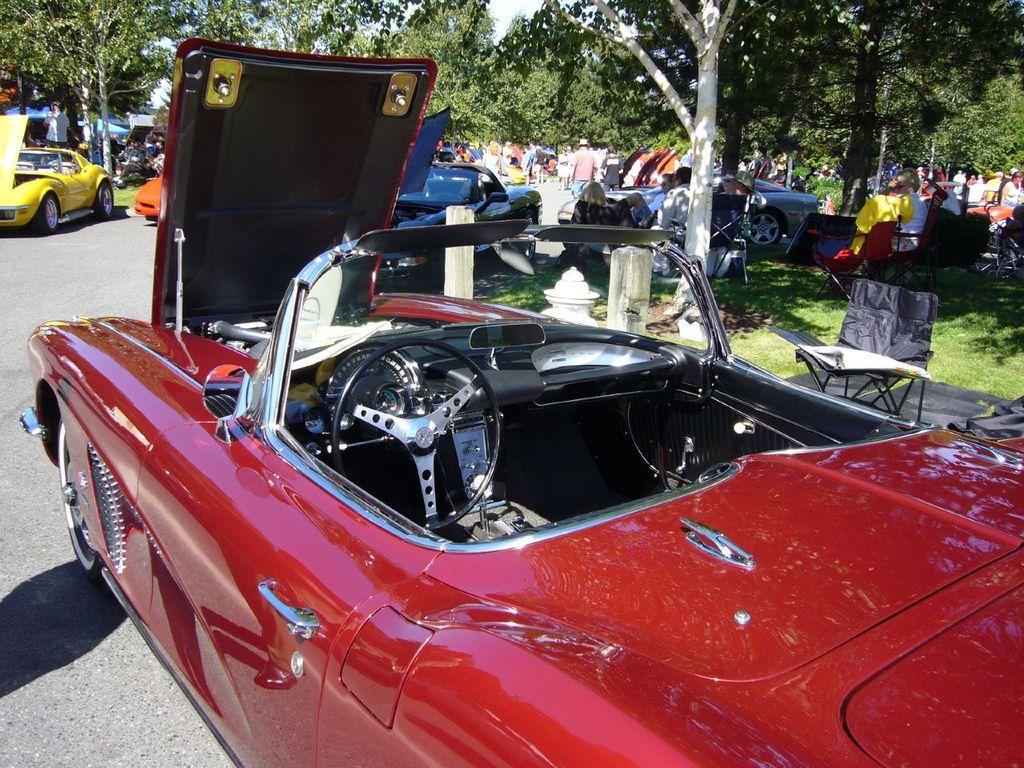Can you describe this image briefly? As we can see in the image there are different colors of cars, grass, few people and trees. 